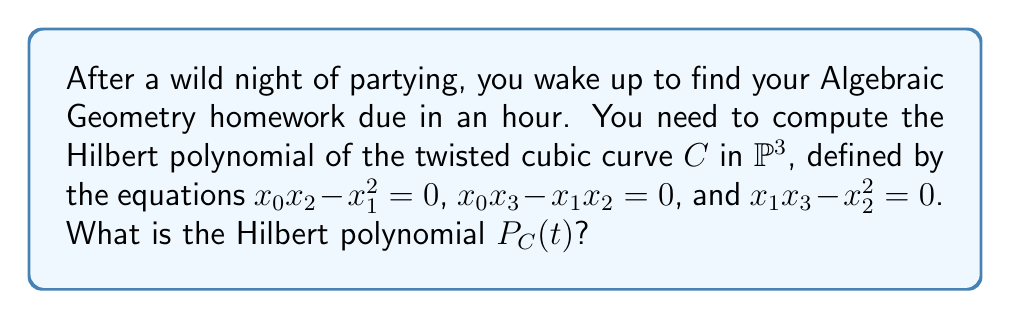Show me your answer to this math problem. Let's approach this step-by-step:

1) The twisted cubic is a curve in $\mathbb{P}^3$, so its dimension is 1.

2) For a curve $C$ of degree $d$ in $\mathbb{P}^3$, the Hilbert polynomial has the general form:

   $$P_C(t) = dt + 1 - g$$

   where $g$ is the arithmetic genus of the curve.

3) To find the degree $d$, we need to count the number of points where $C$ intersects a generic plane. The twisted cubic has degree 3.

4) For the arithmetic genus $g$, we can use the formula for a smooth curve in $\mathbb{P}^3$:

   $$g = \frac{(d-1)(d-2)}{2}$$

5) Substituting $d=3$:

   $$g = \frac{(3-1)(3-2)}{2} = 1$$

6) Now we can write the Hilbert polynomial:

   $$P_C(t) = 3t + 1 - 1 = 3t$$

Thus, the Hilbert polynomial of the twisted cubic is $3t$.
Answer: $3t$ 